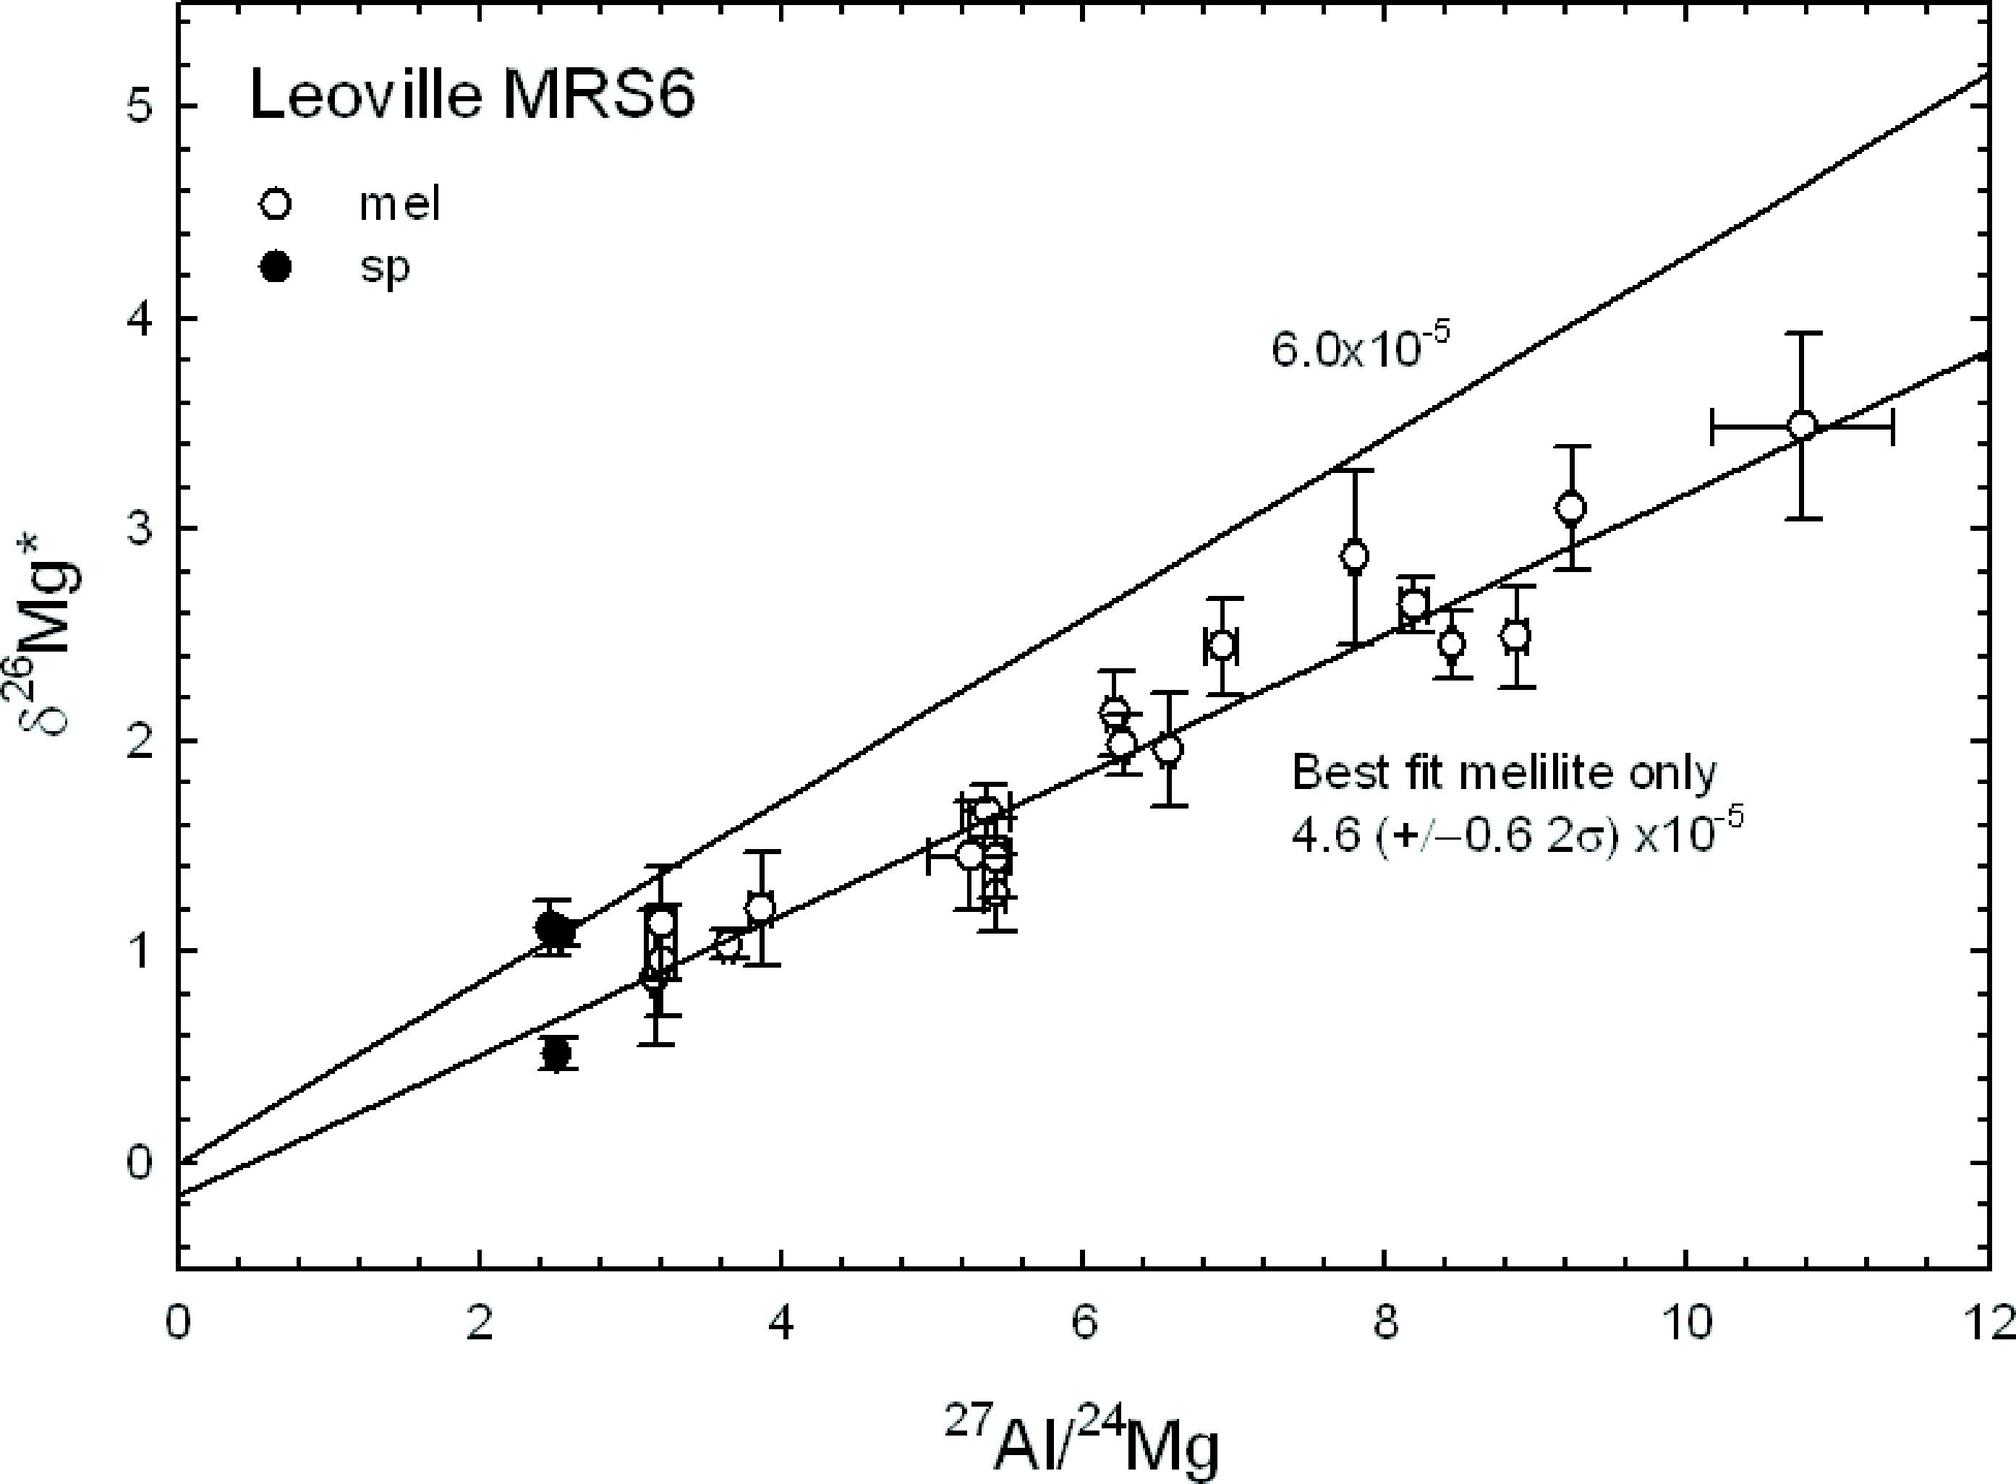What does the intersection of the two trend lines on the graph indicate? The error margin of the data, The point where both sets of data are equal, The starting point of measurements, The maximum value of \/u03b426Mg* recorded The intersection point of the trend lines on the graph represents the moment where the isotopic ratios of Aluminum to Magnesium for melilite and spinel are identical, indicated at approximately \/u03b426Mg* = 1. This corresponds to an identical fractionation factor of these elements for both minerals at this specific isotopic ratio. This equality is critical as it suggests that under the conditions represented at this point, both minerals are equilibrating or sharing similar geochemical conditions. Understanding these intersections helps in deducing the thermodynamic behaviors and environmental variables influencing these minerals during their formation. 